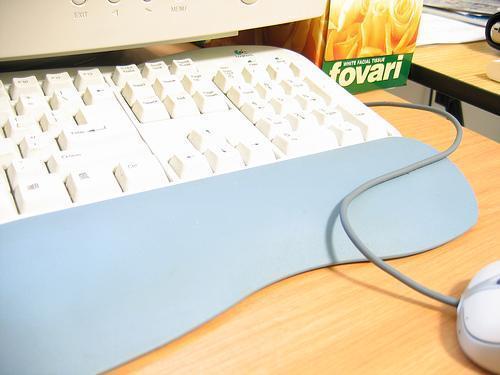How many computer tables are shown?
Give a very brief answer. 2. How many desks are shown?
Give a very brief answer. 2. 